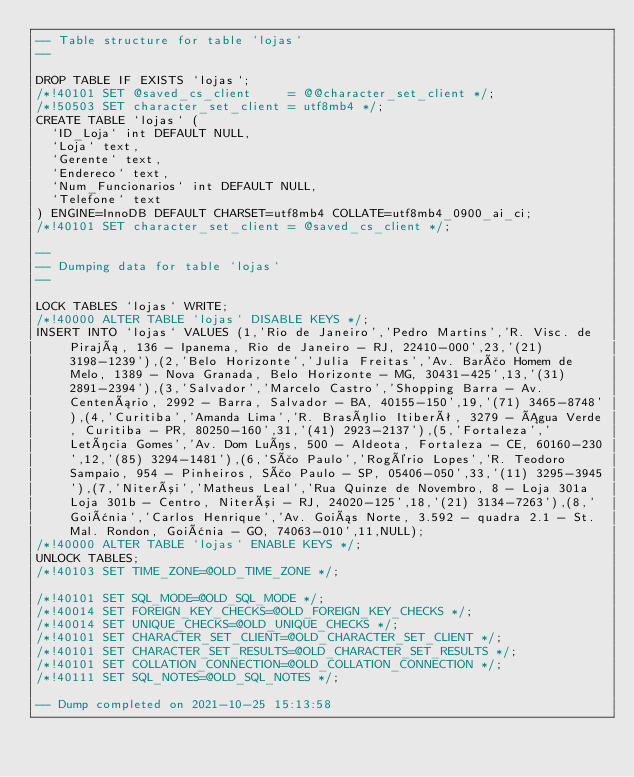Convert code to text. <code><loc_0><loc_0><loc_500><loc_500><_SQL_>-- Table structure for table `lojas`
--

DROP TABLE IF EXISTS `lojas`;
/*!40101 SET @saved_cs_client     = @@character_set_client */;
/*!50503 SET character_set_client = utf8mb4 */;
CREATE TABLE `lojas` (
  `ID_Loja` int DEFAULT NULL,
  `Loja` text,
  `Gerente` text,
  `Endereco` text,
  `Num_Funcionarios` int DEFAULT NULL,
  `Telefone` text
) ENGINE=InnoDB DEFAULT CHARSET=utf8mb4 COLLATE=utf8mb4_0900_ai_ci;
/*!40101 SET character_set_client = @saved_cs_client */;

--
-- Dumping data for table `lojas`
--

LOCK TABLES `lojas` WRITE;
/*!40000 ALTER TABLE `lojas` DISABLE KEYS */;
INSERT INTO `lojas` VALUES (1,'Rio de Janeiro','Pedro Martins','R. Visc. de Pirajá, 136 - Ipanema, Rio de Janeiro - RJ, 22410-000',23,'(21) 3198-1239'),(2,'Belo Horizonte','Julia Freitas','Av. Barão Homem de Melo, 1389 - Nova Granada, Belo Horizonte - MG, 30431-425',13,'(31) 2891-2394'),(3,'Salvador','Marcelo Castro','Shopping Barra - Av. Centenário, 2992 - Barra, Salvador - BA, 40155-150',19,'(71) 3465-8748'),(4,'Curitiba','Amanda Lima','R. Brasílio Itiberê, 3279 - Água Verde, Curitiba - PR, 80250-160',31,'(41) 2923-2137'),(5,'Fortaleza','Letícia Gomes','Av. Dom Luís, 500 - Aldeota, Fortaleza - CE, 60160-230',12,'(85) 3294-1481'),(6,'São Paulo','Rogério Lopes','R. Teodoro Sampaio, 954 - Pinheiros, São Paulo - SP, 05406-050',33,'(11) 3295-3945'),(7,'Niterói','Matheus Leal','Rua Quinze de Novembro, 8 - Loja 301a Loja 301b - Centro, Niterói - RJ, 24020-125',18,'(21) 3134-7263'),(8,'Goiânia','Carlos Henrique','Av. Goiás Norte, 3.592 - quadra 2.1 - St. Mal. Rondon, Goiânia - GO, 74063-010',11,NULL);
/*!40000 ALTER TABLE `lojas` ENABLE KEYS */;
UNLOCK TABLES;
/*!40103 SET TIME_ZONE=@OLD_TIME_ZONE */;

/*!40101 SET SQL_MODE=@OLD_SQL_MODE */;
/*!40014 SET FOREIGN_KEY_CHECKS=@OLD_FOREIGN_KEY_CHECKS */;
/*!40014 SET UNIQUE_CHECKS=@OLD_UNIQUE_CHECKS */;
/*!40101 SET CHARACTER_SET_CLIENT=@OLD_CHARACTER_SET_CLIENT */;
/*!40101 SET CHARACTER_SET_RESULTS=@OLD_CHARACTER_SET_RESULTS */;
/*!40101 SET COLLATION_CONNECTION=@OLD_COLLATION_CONNECTION */;
/*!40111 SET SQL_NOTES=@OLD_SQL_NOTES */;

-- Dump completed on 2021-10-25 15:13:58
</code> 